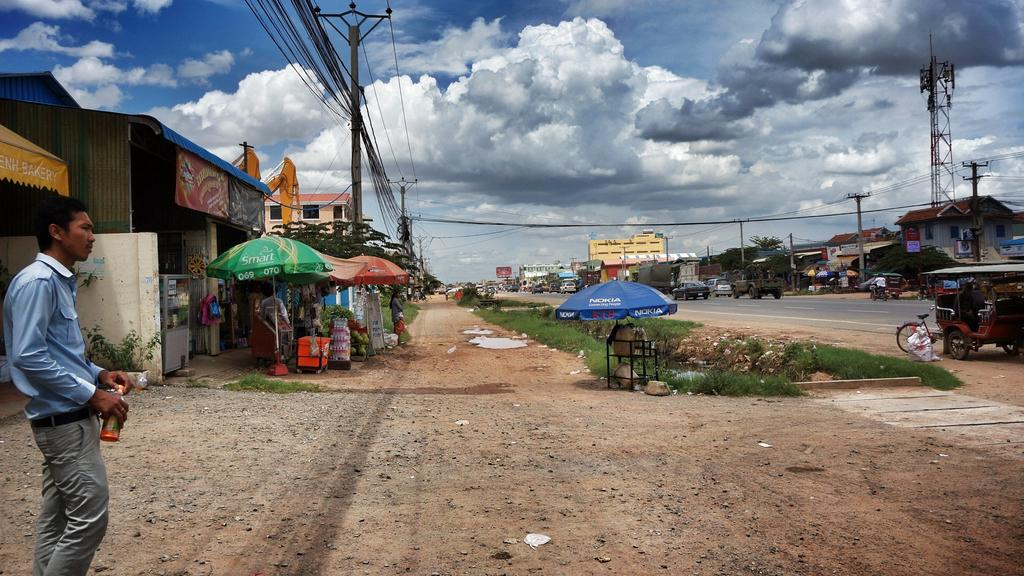What is located on the right side of the image? There are buildings on the right side of the image. What is located on the left side of the image? There are buildings on the left side of the image, and a boy is also present there. What can be seen in the center of the image? There is a path in the center of the image. How many girls are present in the image? There is no mention of girls in the image; only a boy is mentioned. What type of flesh can be seen on the buildings in the image? There is no flesh present in the image; it features buildings and a boy. 